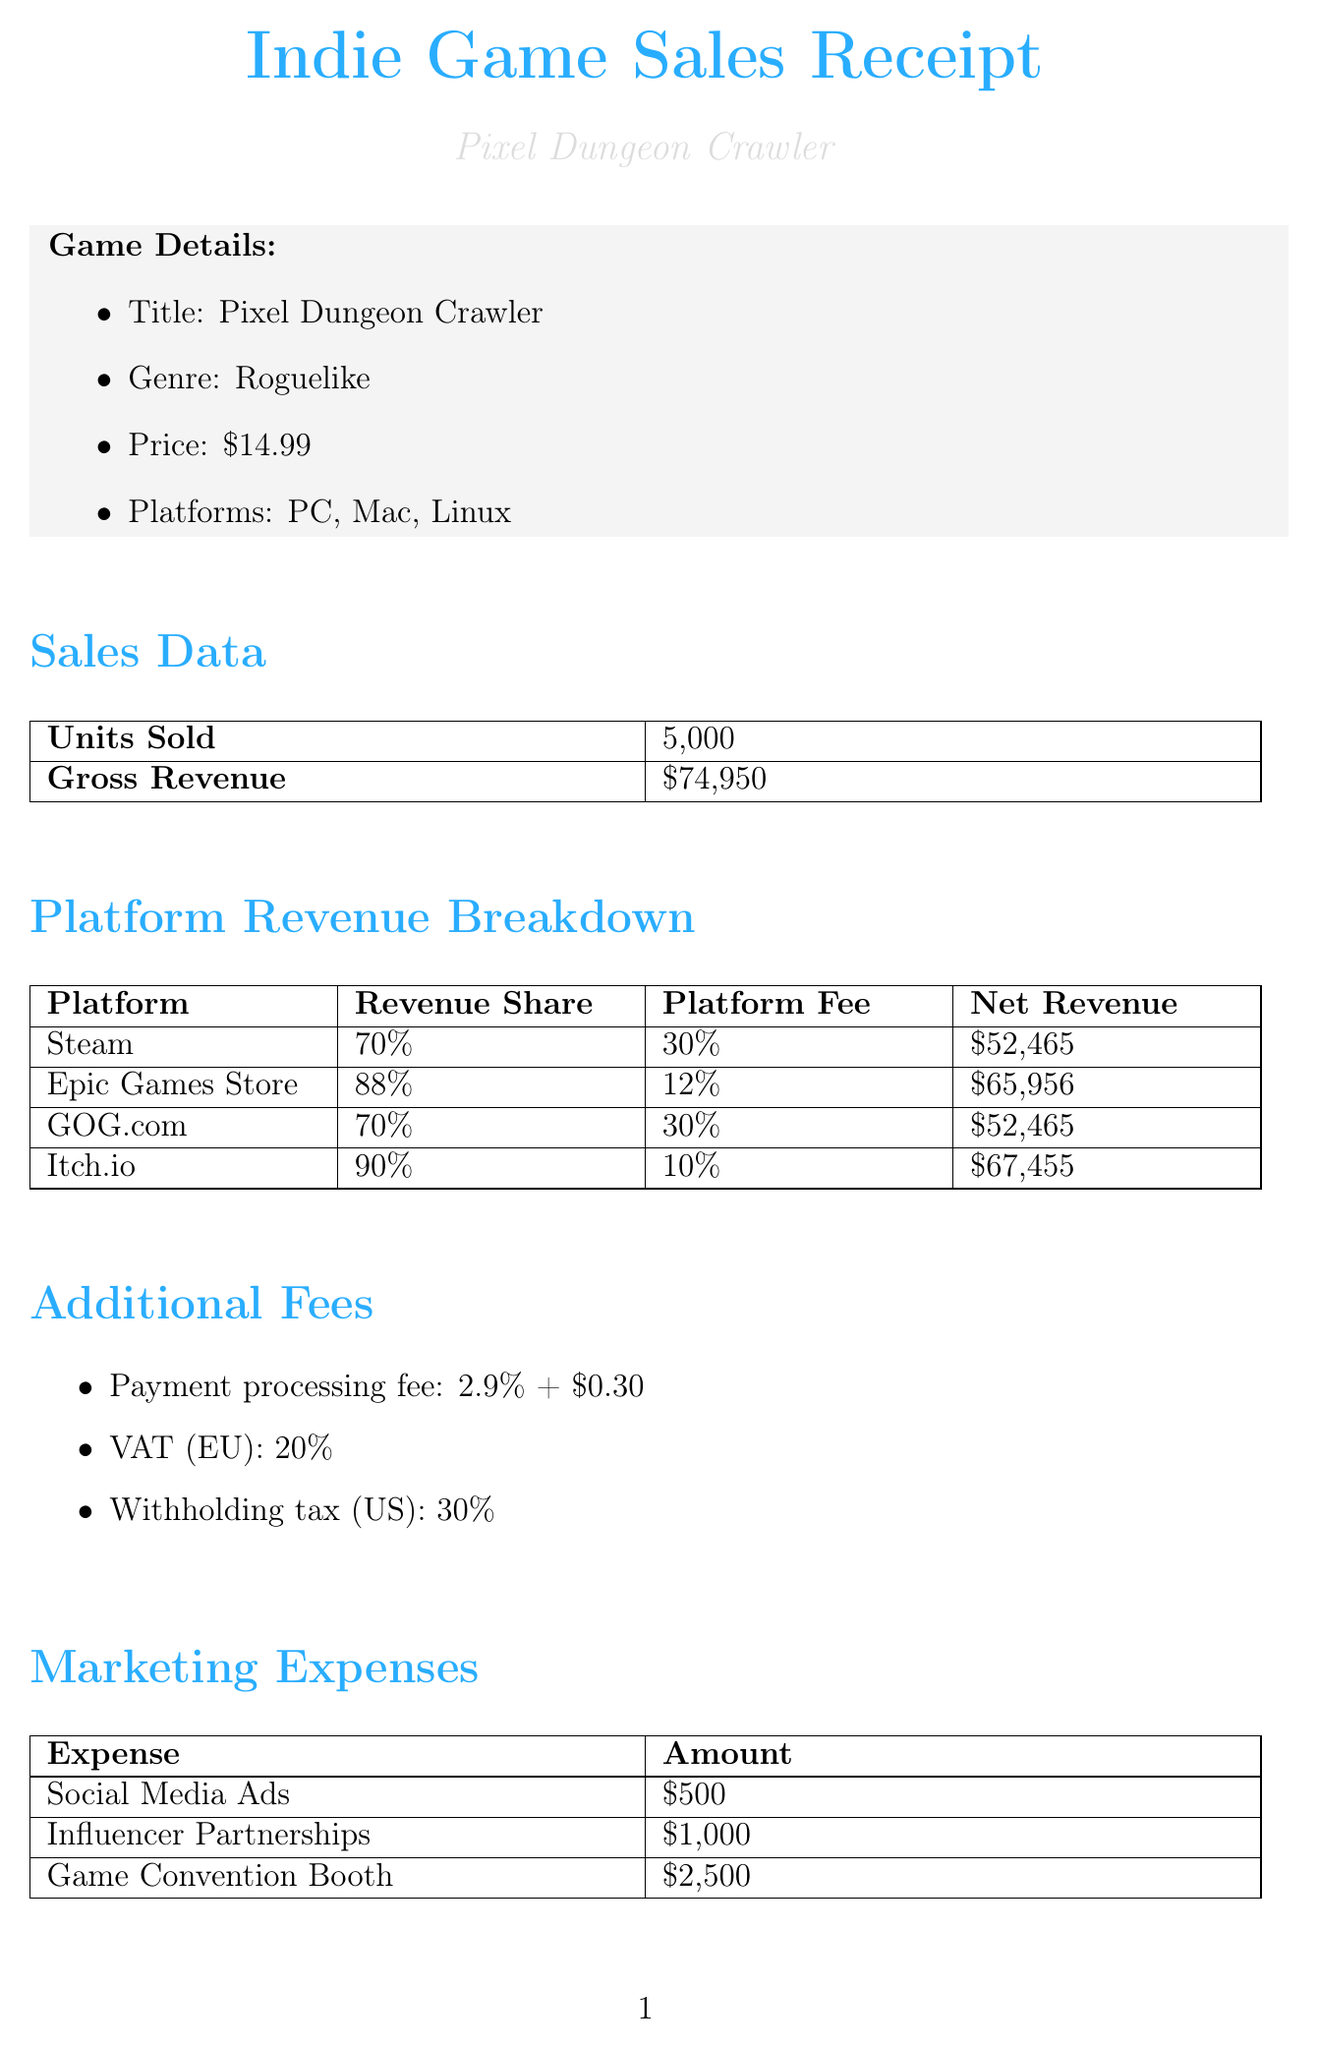What is the price of the game? The price of the game "Pixel Dungeon Crawler" is listed in the game details section as $14.99.
Answer: $14.99 What is the platform fee for Epic Games Store? The platform fee is specified in the revenue breakdown section for Epic Games Store as 12%.
Answer: 12% How many units were sold? The units sold are mentioned in the sales data section as 5,000.
Answer: 5,000 What is the net revenue from Itch.io? The net revenue from Itch.io is listed in the platform revenue breakdown section as $67,455.
Answer: $67,455 What type of game is "Pixel Dungeon Crawler"? The genre of the game is stated in the game details section as Roguelike.
Answer: Roguelike What is the total cost of software licenses? The total cost is summed from the individual software costs in the development costs section. Unity Pro costs $1,800, Adobe Creative Suite costs $600, and Substance Painter costs $150, totaling $2,550.
Answer: $2,550 What is the withholding tax percentage for the US? The withholding tax percentage is mentioned under additional fees as 30%.
Answer: 30% Which platform has the highest revenue share? The revenue share section indicates that Itch.io has the highest revenue share at 90%.
Answer: 90% How much was spent on marketing for the game? The marketing expenses section lists individual expenses totaling $4,000 ($500 + $1,000 + $2,500).
Answer: $4,000 